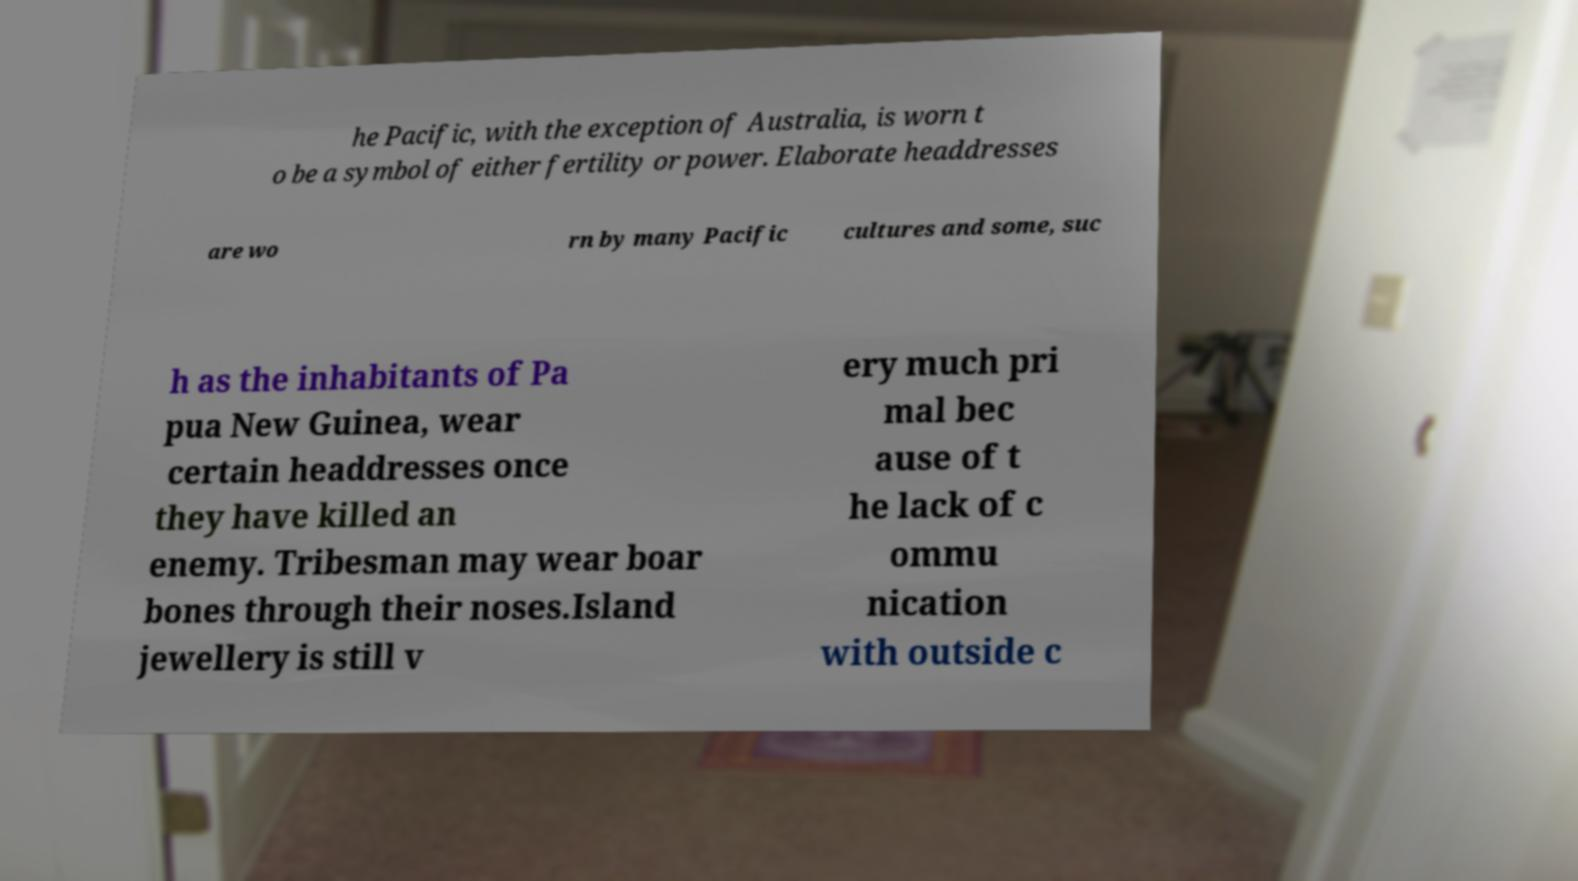Could you extract and type out the text from this image? he Pacific, with the exception of Australia, is worn t o be a symbol of either fertility or power. Elaborate headdresses are wo rn by many Pacific cultures and some, suc h as the inhabitants of Pa pua New Guinea, wear certain headdresses once they have killed an enemy. Tribesman may wear boar bones through their noses.Island jewellery is still v ery much pri mal bec ause of t he lack of c ommu nication with outside c 